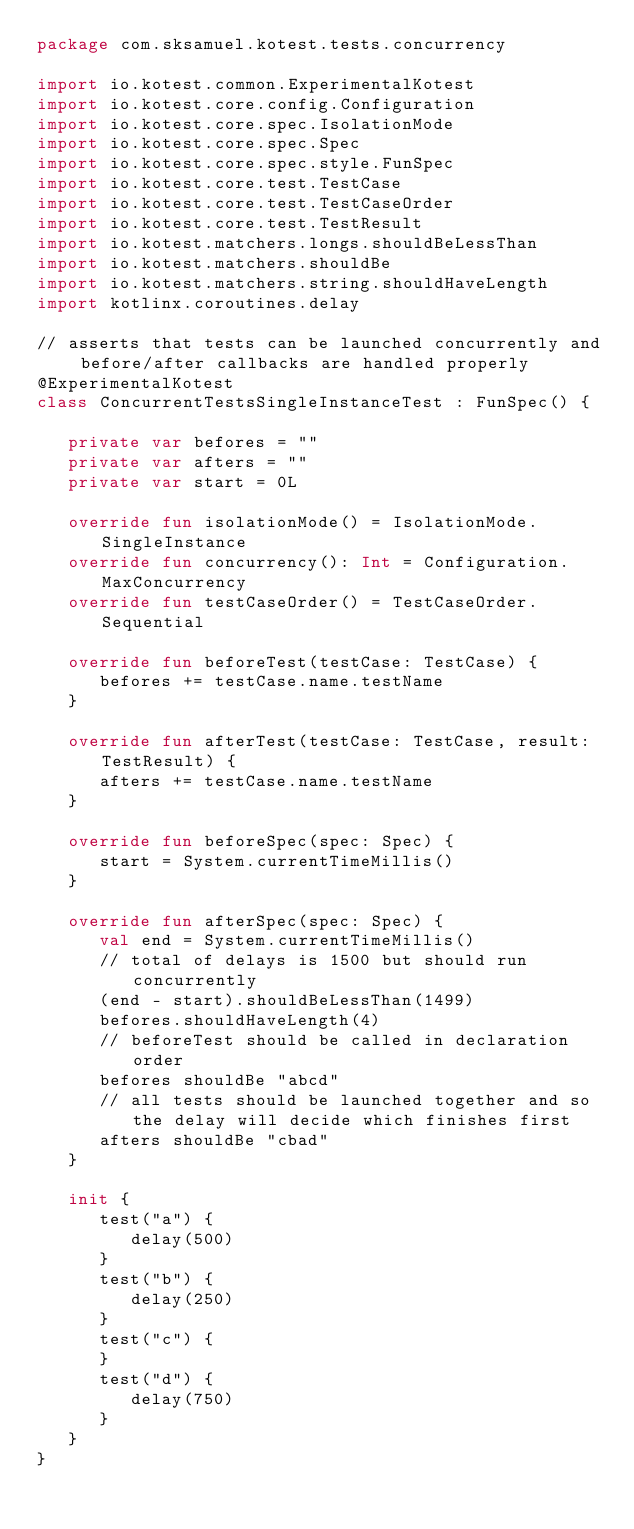Convert code to text. <code><loc_0><loc_0><loc_500><loc_500><_Kotlin_>package com.sksamuel.kotest.tests.concurrency

import io.kotest.common.ExperimentalKotest
import io.kotest.core.config.Configuration
import io.kotest.core.spec.IsolationMode
import io.kotest.core.spec.Spec
import io.kotest.core.spec.style.FunSpec
import io.kotest.core.test.TestCase
import io.kotest.core.test.TestCaseOrder
import io.kotest.core.test.TestResult
import io.kotest.matchers.longs.shouldBeLessThan
import io.kotest.matchers.shouldBe
import io.kotest.matchers.string.shouldHaveLength
import kotlinx.coroutines.delay

// asserts that tests can be launched concurrently and before/after callbacks are handled properly
@ExperimentalKotest
class ConcurrentTestsSingleInstanceTest : FunSpec() {

   private var befores = ""
   private var afters = ""
   private var start = 0L

   override fun isolationMode() = IsolationMode.SingleInstance
   override fun concurrency(): Int = Configuration.MaxConcurrency
   override fun testCaseOrder() = TestCaseOrder.Sequential

   override fun beforeTest(testCase: TestCase) {
      befores += testCase.name.testName
   }

   override fun afterTest(testCase: TestCase, result: TestResult) {
      afters += testCase.name.testName
   }

   override fun beforeSpec(spec: Spec) {
      start = System.currentTimeMillis()
   }

   override fun afterSpec(spec: Spec) {
      val end = System.currentTimeMillis()
      // total of delays is 1500 but should run concurrently
      (end - start).shouldBeLessThan(1499)
      befores.shouldHaveLength(4)
      // beforeTest should be called in declaration order
      befores shouldBe "abcd"
      // all tests should be launched together and so the delay will decide which finishes first
      afters shouldBe "cbad"
   }

   init {
      test("a") {
         delay(500)
      }
      test("b") {
         delay(250)
      }
      test("c") {
      }
      test("d") {
         delay(750)
      }
   }
}
</code> 